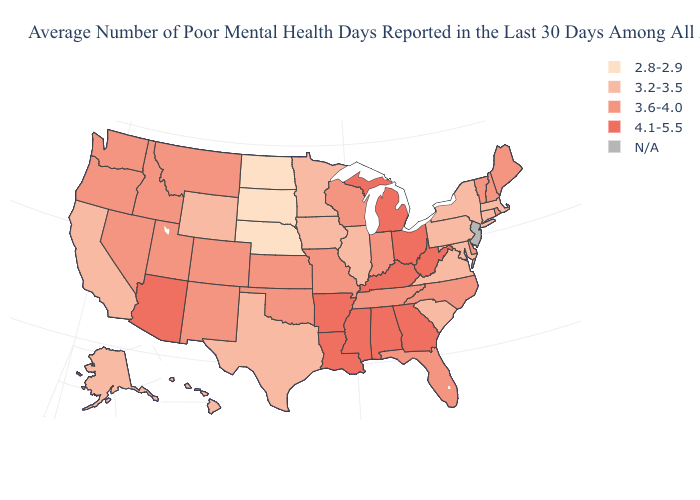What is the lowest value in states that border New Jersey?
Keep it brief. 3.2-3.5. Name the states that have a value in the range 4.1-5.5?
Write a very short answer. Alabama, Arizona, Arkansas, Georgia, Kentucky, Louisiana, Michigan, Mississippi, Ohio, West Virginia. Name the states that have a value in the range 4.1-5.5?
Quick response, please. Alabama, Arizona, Arkansas, Georgia, Kentucky, Louisiana, Michigan, Mississippi, Ohio, West Virginia. What is the value of Oregon?
Short answer required. 3.6-4.0. Name the states that have a value in the range N/A?
Be succinct. New Jersey. Name the states that have a value in the range 3.6-4.0?
Be succinct. Colorado, Delaware, Florida, Idaho, Indiana, Kansas, Maine, Missouri, Montana, Nevada, New Hampshire, New Mexico, North Carolina, Oklahoma, Oregon, Rhode Island, Tennessee, Utah, Vermont, Washington, Wisconsin. What is the value of Kansas?
Write a very short answer. 3.6-4.0. Name the states that have a value in the range 3.6-4.0?
Short answer required. Colorado, Delaware, Florida, Idaho, Indiana, Kansas, Maine, Missouri, Montana, Nevada, New Hampshire, New Mexico, North Carolina, Oklahoma, Oregon, Rhode Island, Tennessee, Utah, Vermont, Washington, Wisconsin. Among the states that border Kansas , does Oklahoma have the lowest value?
Short answer required. No. Name the states that have a value in the range N/A?
Write a very short answer. New Jersey. What is the value of South Carolina?
Concise answer only. 3.2-3.5. Which states hav the highest value in the West?
Concise answer only. Arizona. Does the first symbol in the legend represent the smallest category?
Short answer required. Yes. What is the value of Maine?
Keep it brief. 3.6-4.0. What is the value of Maryland?
Keep it brief. 3.2-3.5. 